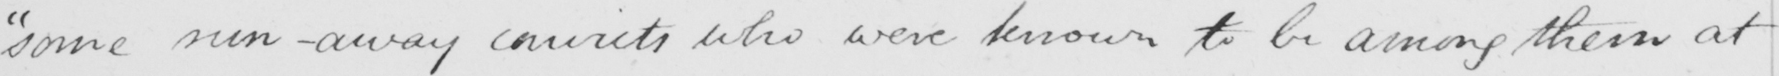Can you read and transcribe this handwriting? "some run-away convicts who were known to be among them at 